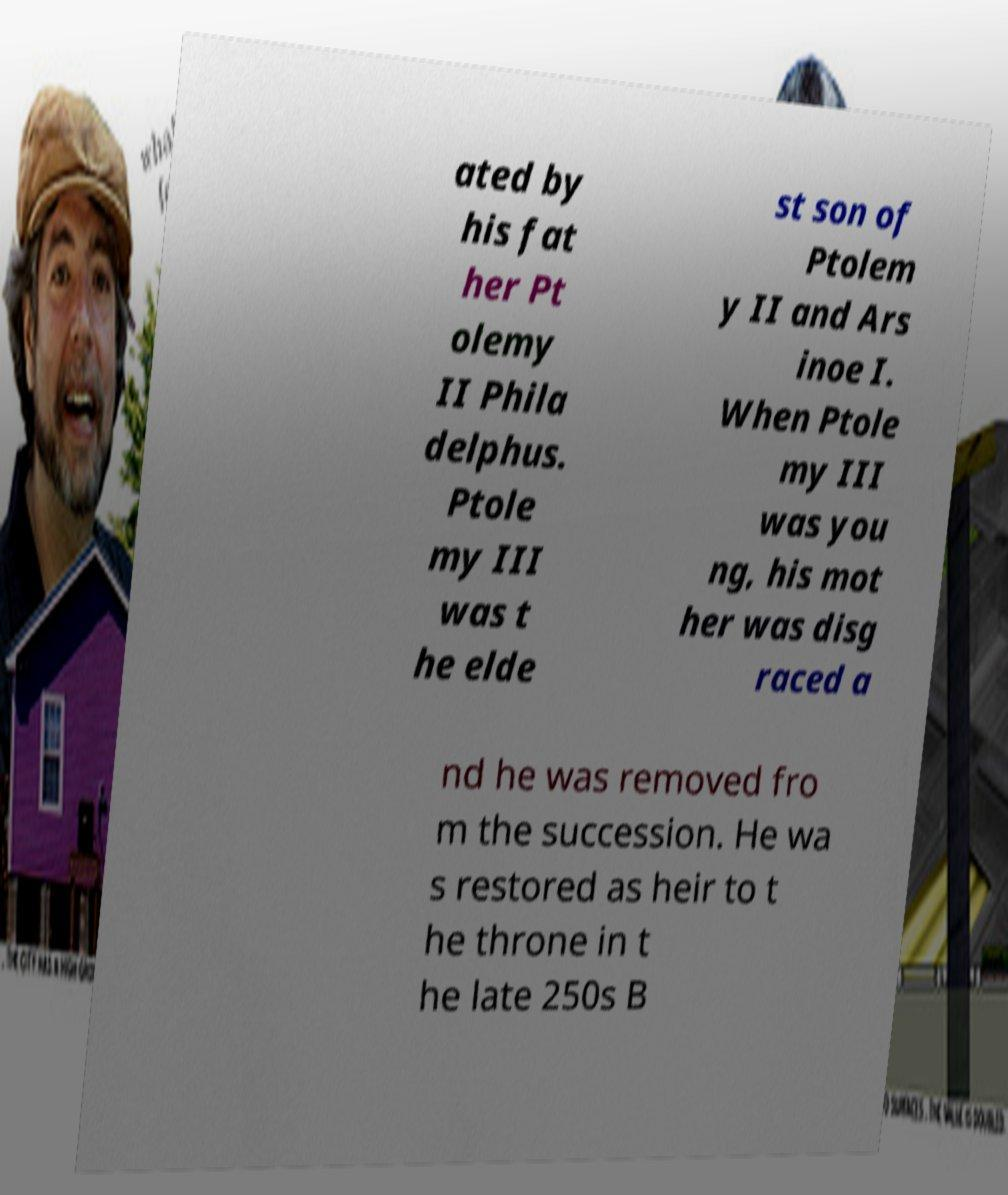Could you assist in decoding the text presented in this image and type it out clearly? ated by his fat her Pt olemy II Phila delphus. Ptole my III was t he elde st son of Ptolem y II and Ars inoe I. When Ptole my III was you ng, his mot her was disg raced a nd he was removed fro m the succession. He wa s restored as heir to t he throne in t he late 250s B 